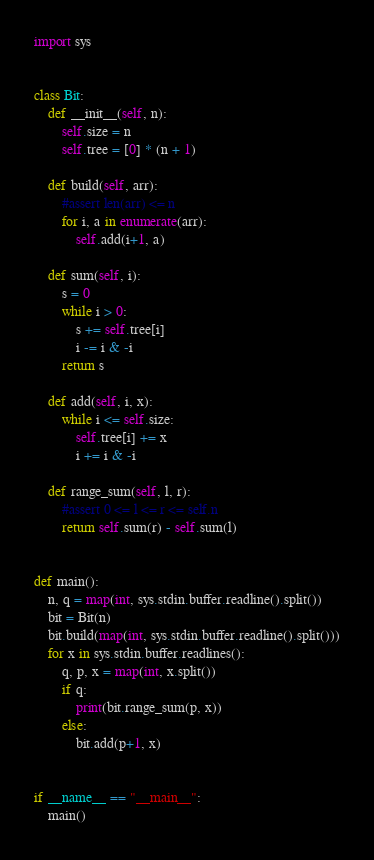Convert code to text. <code><loc_0><loc_0><loc_500><loc_500><_Python_>import sys


class Bit:
    def __init__(self, n):
        self.size = n
        self.tree = [0] * (n + 1)

    def build(self, arr):
        #assert len(arr) <= n
        for i, a in enumerate(arr):
            self.add(i+1, a)

    def sum(self, i):
        s = 0
        while i > 0:
            s += self.tree[i]
            i -= i & -i
        return s

    def add(self, i, x):
        while i <= self.size:
            self.tree[i] += x
            i += i & -i

    def range_sum(self, l, r):
        #assert 0 <= l <= r <= self.n
        return self.sum(r) - self.sum(l)


def main():
    n, q = map(int, sys.stdin.buffer.readline().split())
    bit = Bit(n)
    bit.build(map(int, sys.stdin.buffer.readline().split()))
    for x in sys.stdin.buffer.readlines():
        q, p, x = map(int, x.split())
        if q:
            print(bit.range_sum(p, x))
        else:
            bit.add(p+1, x)


if __name__ == "__main__":
    main()
</code> 